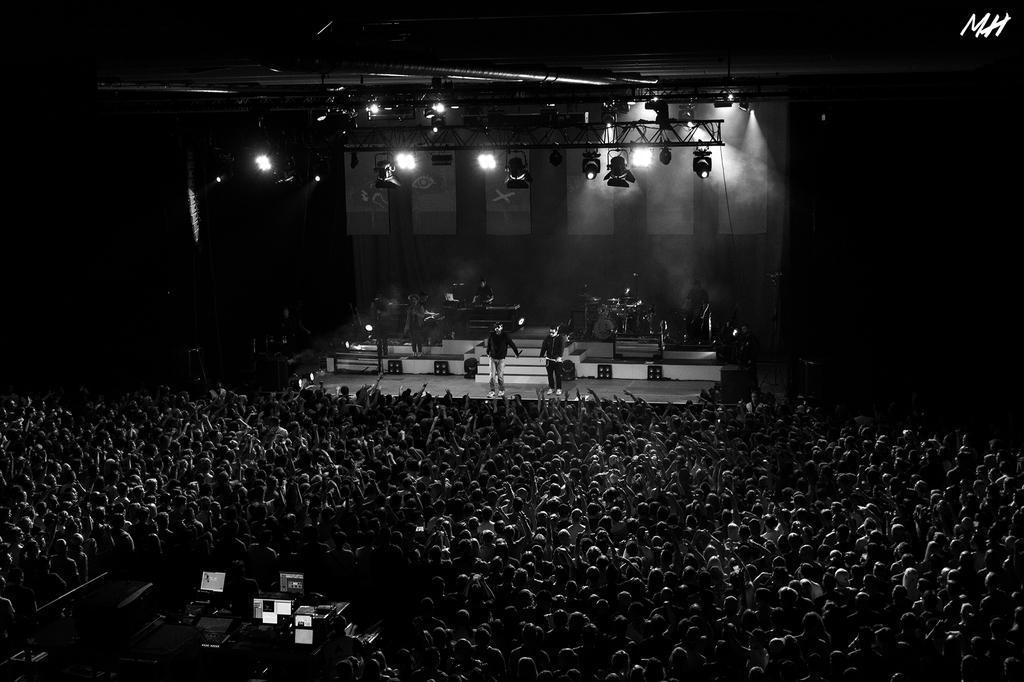Describe this image in one or two sentences. This is a black and white picture, there are few people playing music instruments on the stage and there are many people standing in the front, there are lights over the ceiling. 